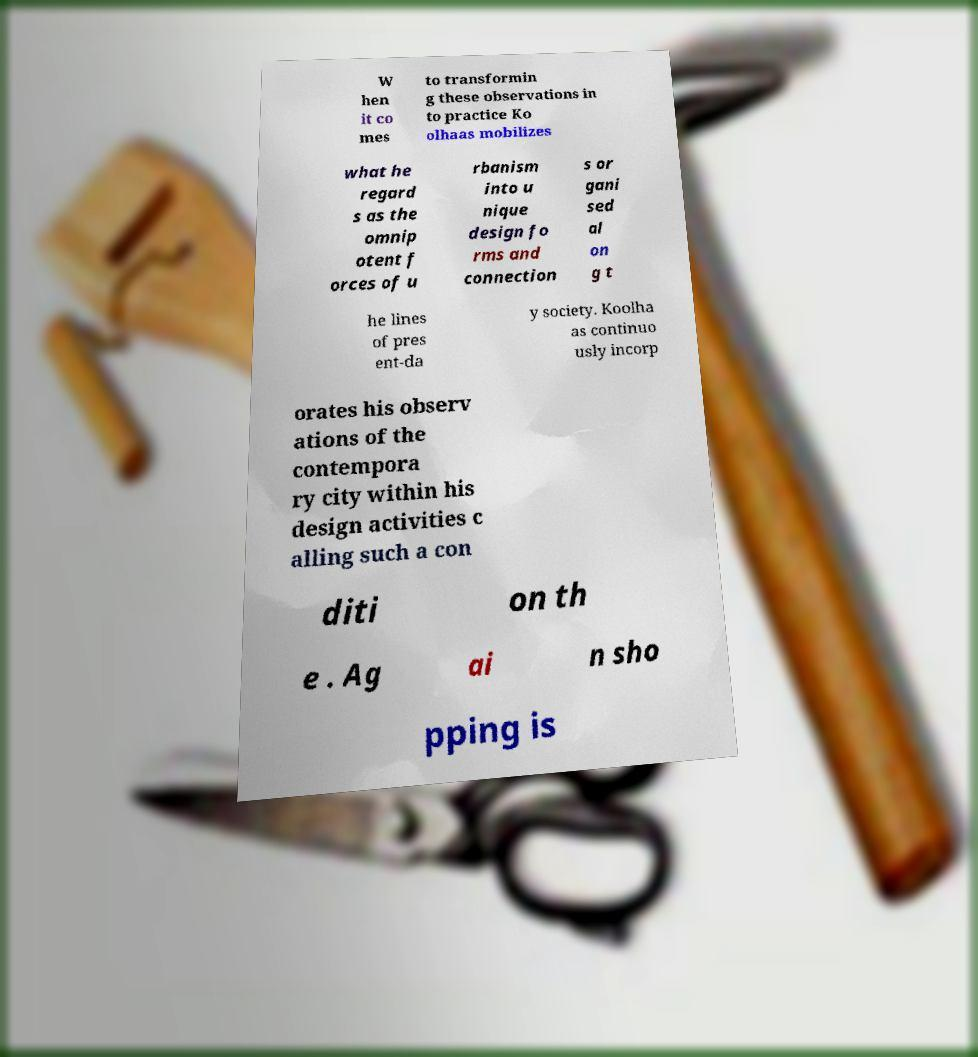Could you extract and type out the text from this image? W hen it co mes to transformin g these observations in to practice Ko olhaas mobilizes what he regard s as the omnip otent f orces of u rbanism into u nique design fo rms and connection s or gani sed al on g t he lines of pres ent-da y society. Koolha as continuo usly incorp orates his observ ations of the contempora ry city within his design activities c alling such a con diti on th e . Ag ai n sho pping is 